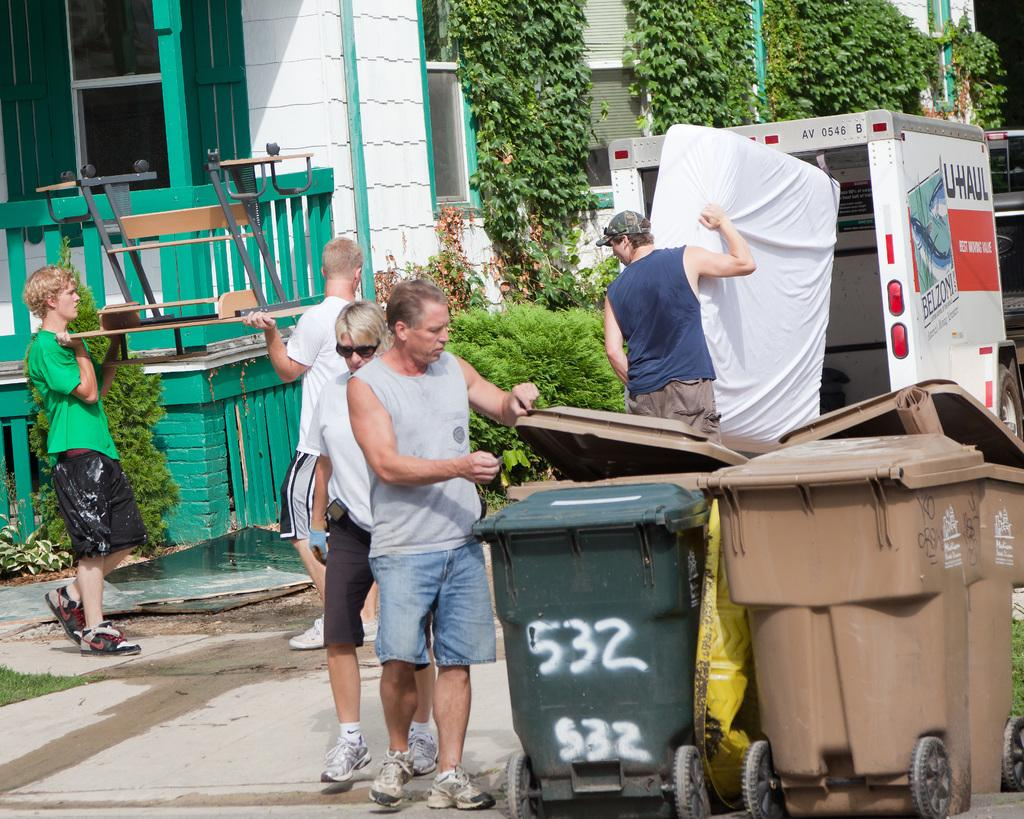Provide a one-sentence caption for the provided image. Men load furniture including a mattress into a U-Haul truck. 